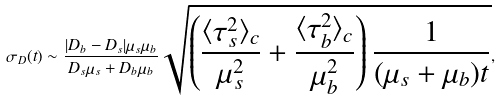<formula> <loc_0><loc_0><loc_500><loc_500>\sigma _ { D } ( t ) \sim \frac { | D _ { b } - D _ { s } | \mu _ { s } \mu _ { b } } { D _ { s } \mu _ { s } + D _ { b } \mu _ { b } } \sqrt { \left ( \frac { \langle \tau _ { s } ^ { 2 } \rangle _ { c } } { \mu _ { s } ^ { 2 } } + \frac { \langle \tau _ { b } ^ { 2 } \rangle _ { c } } { \mu _ { b } ^ { 2 } } \right ) \frac { 1 } { ( \mu _ { s } + \mu _ { b } ) t } } ,</formula> 